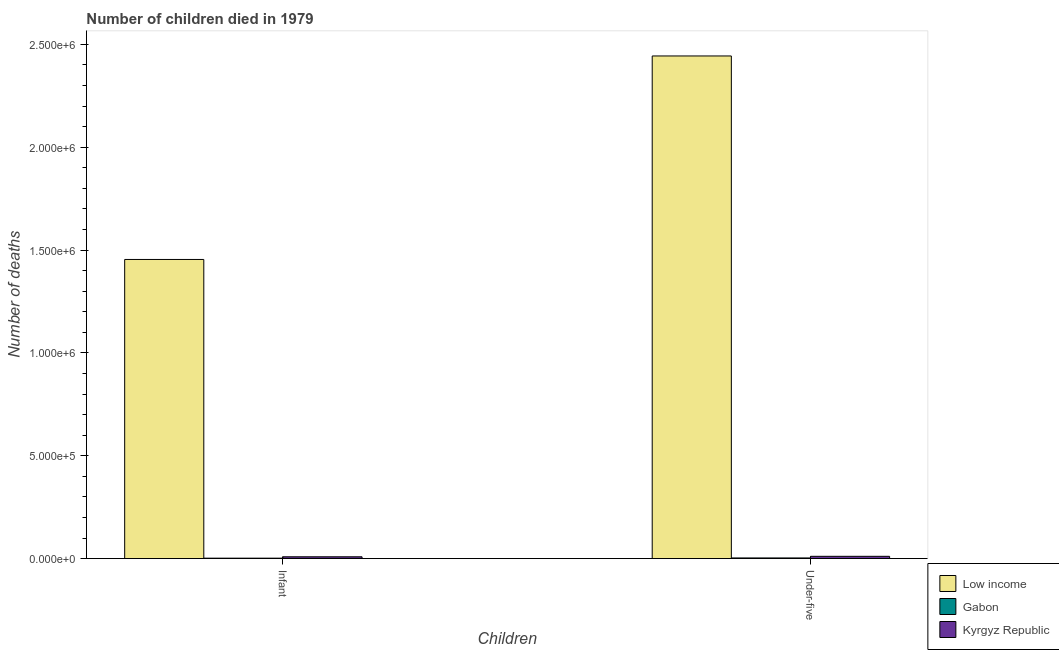How many groups of bars are there?
Make the answer very short. 2. Are the number of bars per tick equal to the number of legend labels?
Ensure brevity in your answer.  Yes. Are the number of bars on each tick of the X-axis equal?
Offer a very short reply. Yes. What is the label of the 1st group of bars from the left?
Your answer should be very brief. Infant. What is the number of under-five deaths in Kyrgyz Republic?
Make the answer very short. 1.09e+04. Across all countries, what is the maximum number of infant deaths?
Offer a terse response. 1.45e+06. Across all countries, what is the minimum number of infant deaths?
Ensure brevity in your answer.  1974. In which country was the number of infant deaths minimum?
Your answer should be compact. Gabon. What is the total number of under-five deaths in the graph?
Keep it short and to the point. 2.46e+06. What is the difference between the number of infant deaths in Kyrgyz Republic and that in Gabon?
Make the answer very short. 6640. What is the difference between the number of under-five deaths in Low income and the number of infant deaths in Kyrgyz Republic?
Your answer should be very brief. 2.44e+06. What is the average number of under-five deaths per country?
Provide a succinct answer. 8.19e+05. What is the difference between the number of under-five deaths and number of infant deaths in Kyrgyz Republic?
Offer a terse response. 2284. What is the ratio of the number of infant deaths in Gabon to that in Low income?
Offer a terse response. 0. What does the 1st bar from the left in Infant represents?
Keep it short and to the point. Low income. What does the 2nd bar from the right in Under-five represents?
Make the answer very short. Gabon. How many bars are there?
Offer a terse response. 6. Are all the bars in the graph horizontal?
Provide a short and direct response. No. How many countries are there in the graph?
Your answer should be very brief. 3. Where does the legend appear in the graph?
Your answer should be compact. Bottom right. How are the legend labels stacked?
Give a very brief answer. Vertical. What is the title of the graph?
Your response must be concise. Number of children died in 1979. Does "Bahrain" appear as one of the legend labels in the graph?
Provide a short and direct response. No. What is the label or title of the X-axis?
Make the answer very short. Children. What is the label or title of the Y-axis?
Your response must be concise. Number of deaths. What is the Number of deaths of Low income in Infant?
Give a very brief answer. 1.45e+06. What is the Number of deaths of Gabon in Infant?
Offer a very short reply. 1974. What is the Number of deaths in Kyrgyz Republic in Infant?
Make the answer very short. 8614. What is the Number of deaths in Low income in Under-five?
Provide a succinct answer. 2.44e+06. What is the Number of deaths in Gabon in Under-five?
Give a very brief answer. 3067. What is the Number of deaths in Kyrgyz Republic in Under-five?
Your response must be concise. 1.09e+04. Across all Children, what is the maximum Number of deaths of Low income?
Your answer should be compact. 2.44e+06. Across all Children, what is the maximum Number of deaths in Gabon?
Ensure brevity in your answer.  3067. Across all Children, what is the maximum Number of deaths in Kyrgyz Republic?
Make the answer very short. 1.09e+04. Across all Children, what is the minimum Number of deaths of Low income?
Provide a succinct answer. 1.45e+06. Across all Children, what is the minimum Number of deaths of Gabon?
Give a very brief answer. 1974. Across all Children, what is the minimum Number of deaths of Kyrgyz Republic?
Offer a terse response. 8614. What is the total Number of deaths in Low income in the graph?
Offer a very short reply. 3.90e+06. What is the total Number of deaths in Gabon in the graph?
Provide a short and direct response. 5041. What is the total Number of deaths in Kyrgyz Republic in the graph?
Your answer should be compact. 1.95e+04. What is the difference between the Number of deaths in Low income in Infant and that in Under-five?
Make the answer very short. -9.89e+05. What is the difference between the Number of deaths of Gabon in Infant and that in Under-five?
Your answer should be compact. -1093. What is the difference between the Number of deaths of Kyrgyz Republic in Infant and that in Under-five?
Offer a terse response. -2284. What is the difference between the Number of deaths in Low income in Infant and the Number of deaths in Gabon in Under-five?
Your answer should be very brief. 1.45e+06. What is the difference between the Number of deaths of Low income in Infant and the Number of deaths of Kyrgyz Republic in Under-five?
Offer a terse response. 1.44e+06. What is the difference between the Number of deaths of Gabon in Infant and the Number of deaths of Kyrgyz Republic in Under-five?
Ensure brevity in your answer.  -8924. What is the average Number of deaths in Low income per Children?
Provide a succinct answer. 1.95e+06. What is the average Number of deaths of Gabon per Children?
Provide a short and direct response. 2520.5. What is the average Number of deaths of Kyrgyz Republic per Children?
Provide a succinct answer. 9756. What is the difference between the Number of deaths of Low income and Number of deaths of Gabon in Infant?
Your answer should be very brief. 1.45e+06. What is the difference between the Number of deaths of Low income and Number of deaths of Kyrgyz Republic in Infant?
Keep it short and to the point. 1.45e+06. What is the difference between the Number of deaths of Gabon and Number of deaths of Kyrgyz Republic in Infant?
Ensure brevity in your answer.  -6640. What is the difference between the Number of deaths of Low income and Number of deaths of Gabon in Under-five?
Your answer should be very brief. 2.44e+06. What is the difference between the Number of deaths of Low income and Number of deaths of Kyrgyz Republic in Under-five?
Provide a succinct answer. 2.43e+06. What is the difference between the Number of deaths of Gabon and Number of deaths of Kyrgyz Republic in Under-five?
Make the answer very short. -7831. What is the ratio of the Number of deaths in Low income in Infant to that in Under-five?
Ensure brevity in your answer.  0.6. What is the ratio of the Number of deaths in Gabon in Infant to that in Under-five?
Make the answer very short. 0.64. What is the ratio of the Number of deaths of Kyrgyz Republic in Infant to that in Under-five?
Your answer should be very brief. 0.79. What is the difference between the highest and the second highest Number of deaths in Low income?
Ensure brevity in your answer.  9.89e+05. What is the difference between the highest and the second highest Number of deaths in Gabon?
Give a very brief answer. 1093. What is the difference between the highest and the second highest Number of deaths in Kyrgyz Republic?
Keep it short and to the point. 2284. What is the difference between the highest and the lowest Number of deaths of Low income?
Make the answer very short. 9.89e+05. What is the difference between the highest and the lowest Number of deaths in Gabon?
Offer a terse response. 1093. What is the difference between the highest and the lowest Number of deaths in Kyrgyz Republic?
Offer a very short reply. 2284. 